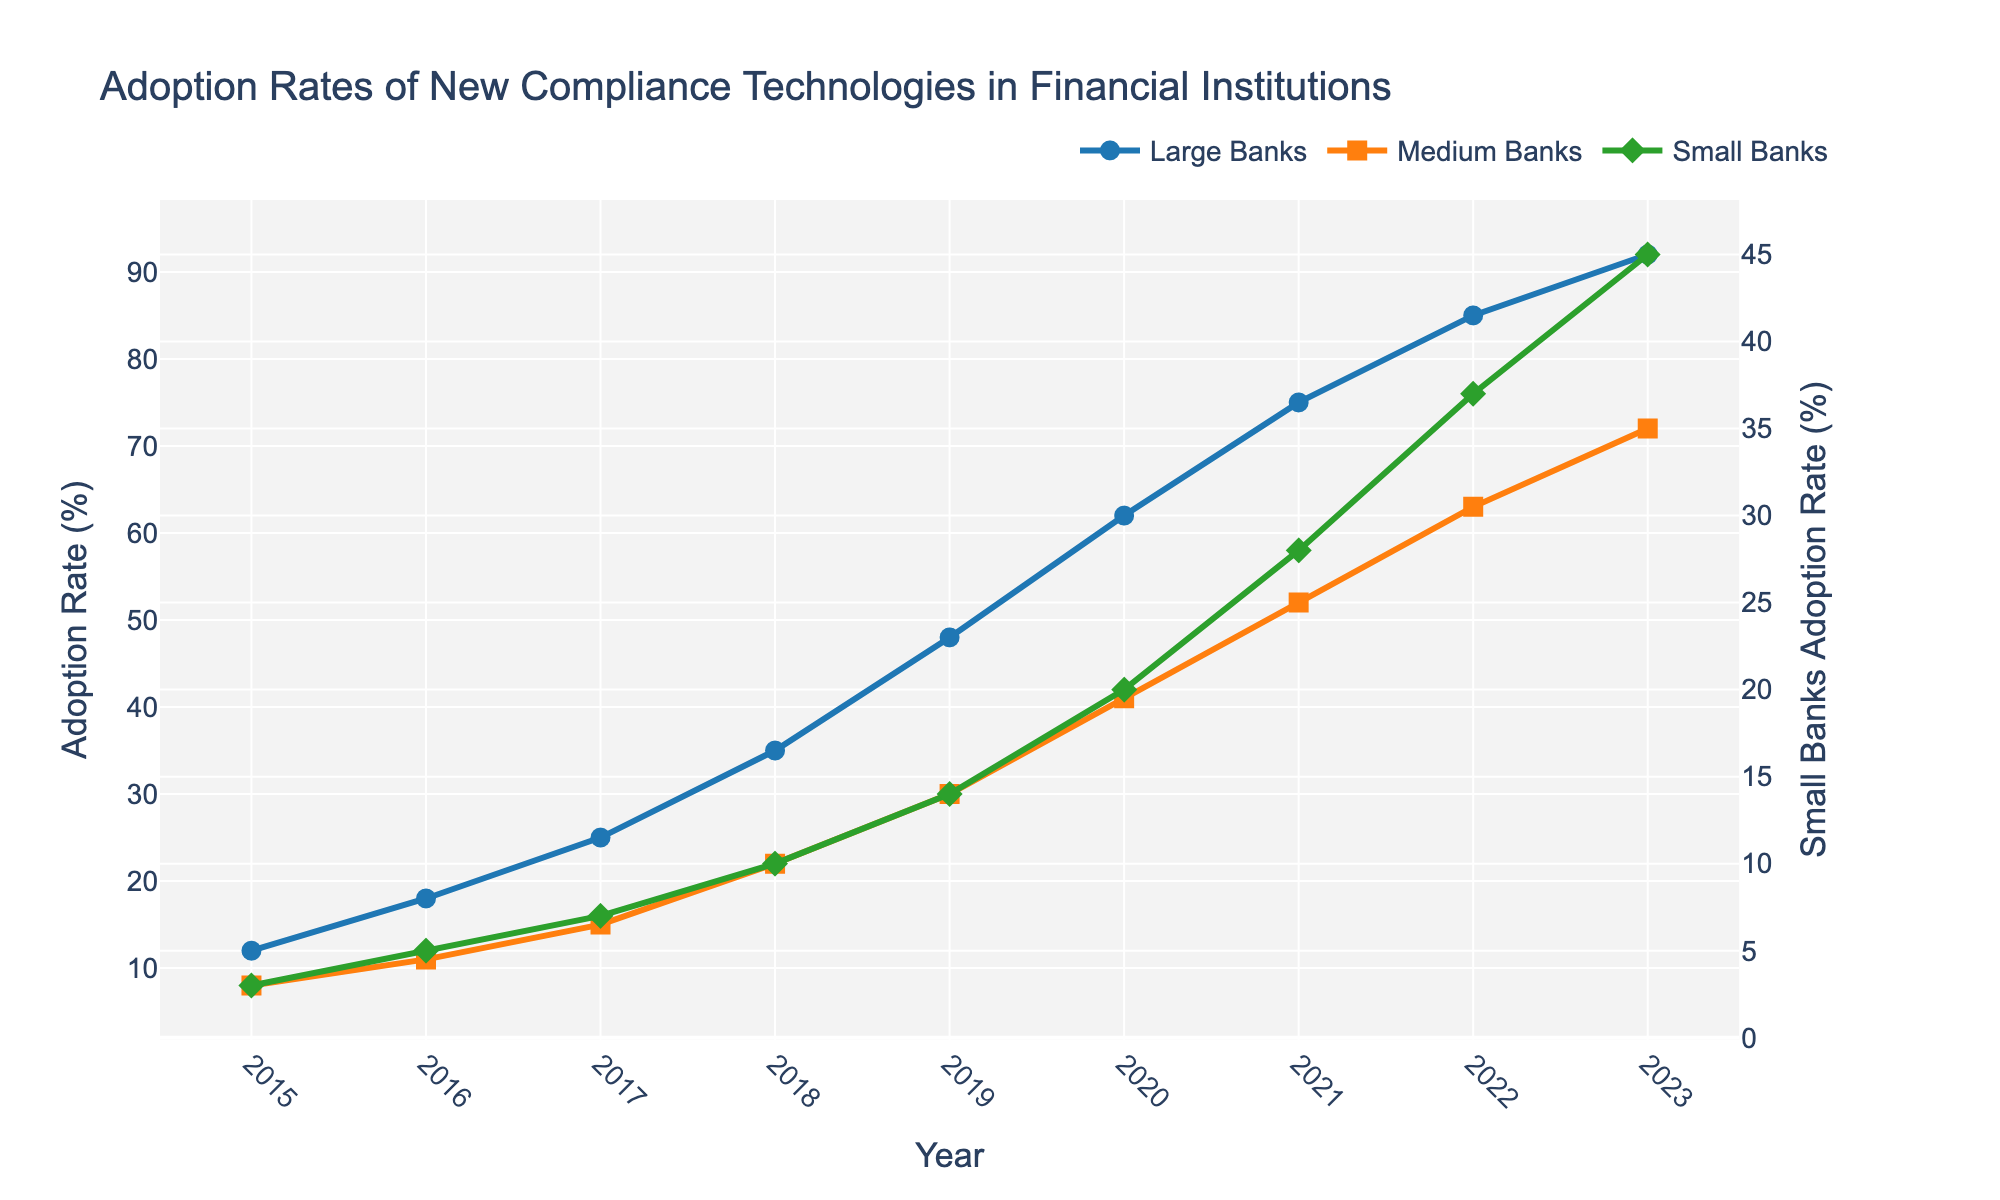What year did large banks first exceed a 50% adoption rate? According to the line plot, large banks exceeded a 50% adoption rate in the year 2020. This is evident because the line corresponding to large banks (blue line) passes the 50% mark in 2020.
Answer: 2020 Which year shows the smallest difference in adoption rates between medium and small banks? By examining the vertical distances between the orange line (medium banks) and the green line (small banks) across the years, the closest proximity occurs in 2016. In that year, medium banks had an adoption rate of 11%, and small banks had 5%, resulting in a difference of 6%.
Answer: 2016 What was the adoption rate for small banks in 2022? The green line corresponding to small banks reaches 37% in the year 2022. This can be confirmed by looking at the y-axis measurement for the diamond marker on the green line for that year.
Answer: 37% If the adoption rate trends continued, estimate the adoption rate for large banks in 2025. We can observe that large banks (blue line) increased their adoption rate by approximately 3 to 10 percentage points annually. If we project a similar annual increase of about 7 percentage points (the average from 2022 to 2023), the projected adoption rate in 2025 would be around 106% (92% + (2 x 7%)). However, since adoption rates cannot exceed 100%, the adoption rate would realistically plateau at 100%.
Answer: 100% By how much did the adoption rate increase for medium banks from 2019 to 2020? The adoption rate for medium banks (orange line) increased from 30% in 2019 to 41% in 2020. The increase can be calculated as 41% - 30% = 11%.
Answer: 11% Which category of banks had the most significant increase in adoption rate between 2018 and 2019? From the figure, we see that:
- Large banks increased from 35% to 48%, a rise of 13%.
- Medium banks increased from 22% to 30%, a rise of 8%.
- Small banks increased from 10% to 14%, a rise of 4%.
Therefore, large banks had the most significant increase.
Answer: Large banks What is the average adoption rate for medium banks over the observed period? The adoption rates for medium banks each year are 8%, 11%, 15%, 22%, 30%, 41%, 52%, 63%, and 72%. Summing these rates: 8 + 11 + 15 + 22 + 30 + 41 + 52 + 63 + 72 = 314. Dividing by the number of years, 314 / 9 = approximately 34.89%.
Answer: 34.89% Which bank category reached a 20% adoption rate earliest? From observing the lines:
- Small banks reached 20% in 2020.
- Medium banks reached 20% in 2018.
- Large banks reached 20% in 2016.
Thus, large banks reached a 20% adoption rate the earliest in 2016.
Answer: Large banks 